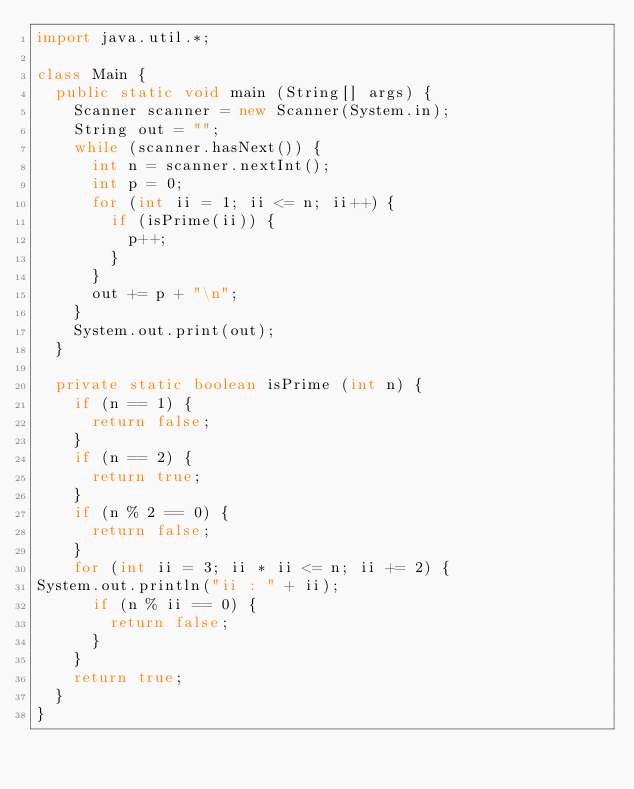Convert code to text. <code><loc_0><loc_0><loc_500><loc_500><_Java_>import java.util.*;

class Main {
  public static void main (String[] args) {
    Scanner scanner = new Scanner(System.in);
    String out = "";
    while (scanner.hasNext()) {
      int n = scanner.nextInt();
      int p = 0;
      for (int ii = 1; ii <= n; ii++) {
        if (isPrime(ii)) {
          p++;
        }
      }
      out += p + "\n";
    }
    System.out.print(out);
  }

  private static boolean isPrime (int n) {
    if (n == 1) {
      return false;
    }
    if (n == 2) {
      return true;
    }
    if (n % 2 == 0) {
      return false;
    }
    for (int ii = 3; ii * ii <= n; ii += 2) {
System.out.println("ii : " + ii);
      if (n % ii == 0) {
        return false;
      }
    }
    return true;
  }
}</code> 